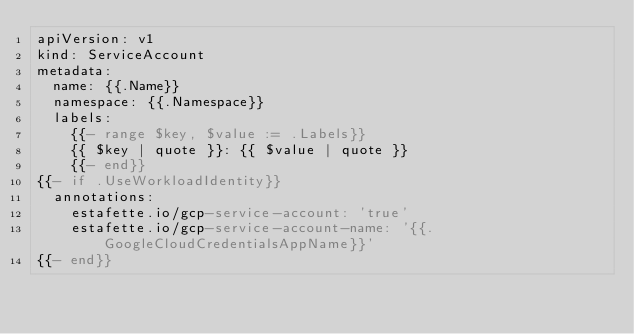<code> <loc_0><loc_0><loc_500><loc_500><_YAML_>apiVersion: v1
kind: ServiceAccount
metadata:
  name: {{.Name}}
  namespace: {{.Namespace}}
  labels:
    {{- range $key, $value := .Labels}}
    {{ $key | quote }}: {{ $value | quote }}
    {{- end}}
{{- if .UseWorkloadIdentity}}
  annotations:
    estafette.io/gcp-service-account: 'true'
    estafette.io/gcp-service-account-name: '{{.GoogleCloudCredentialsAppName}}'
{{- end}}</code> 